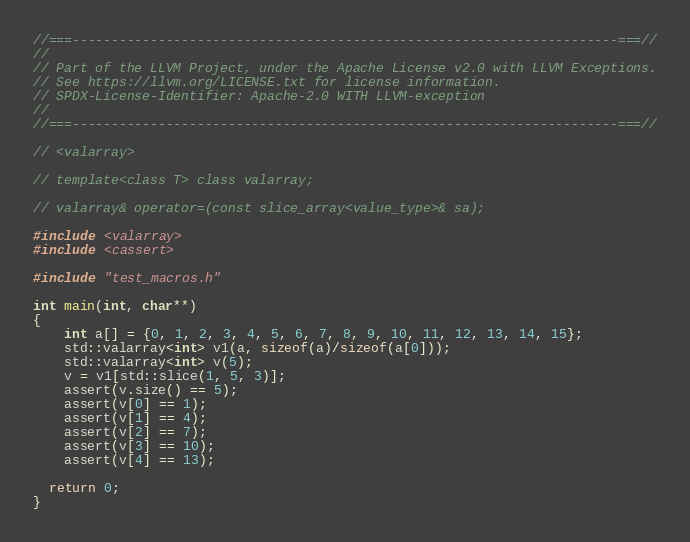Convert code to text. <code><loc_0><loc_0><loc_500><loc_500><_C++_>//===----------------------------------------------------------------------===//
//
// Part of the LLVM Project, under the Apache License v2.0 with LLVM Exceptions.
// See https://llvm.org/LICENSE.txt for license information.
// SPDX-License-Identifier: Apache-2.0 WITH LLVM-exception
//
//===----------------------------------------------------------------------===//

// <valarray>

// template<class T> class valarray;

// valarray& operator=(const slice_array<value_type>& sa);

#include <valarray>
#include <cassert>

#include "test_macros.h"

int main(int, char**)
{
    int a[] = {0, 1, 2, 3, 4, 5, 6, 7, 8, 9, 10, 11, 12, 13, 14, 15};
    std::valarray<int> v1(a, sizeof(a)/sizeof(a[0]));
    std::valarray<int> v(5);
    v = v1[std::slice(1, 5, 3)];
    assert(v.size() == 5);
    assert(v[0] == 1);
    assert(v[1] == 4);
    assert(v[2] == 7);
    assert(v[3] == 10);
    assert(v[4] == 13);

  return 0;
}
</code> 